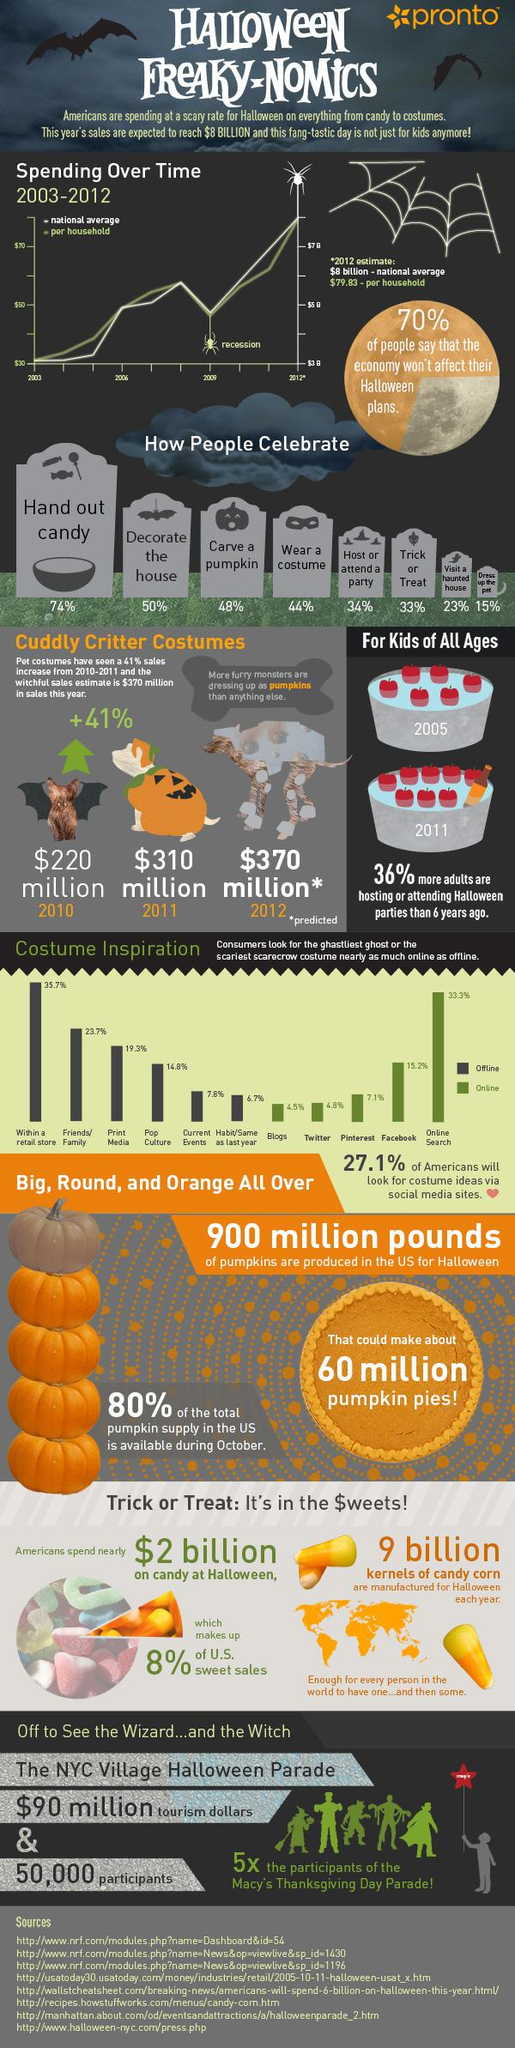Point out several critical features in this image. According to recent data, 15.2% of people use Facebook to search for Halloween costume ideas. According to a recent survey, 23% of Americans report visiting haunted houses or "ghost houses" during the Halloween season. According to a survey, 70% of Americans believe that their income should not be a factor in celebrating Halloween. On the online platform Pinterest, the third-highest number of Halloween searches are conducted. The popularity of Halloween celebrations in America first gained widespread recognition in 2006. 